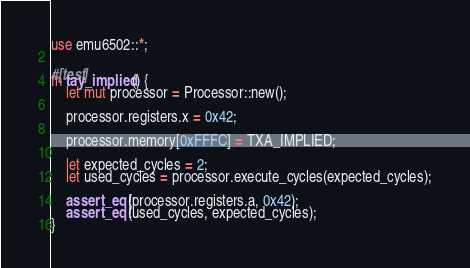Convert code to text. <code><loc_0><loc_0><loc_500><loc_500><_Rust_>use emu6502::*;

#[test]
fn tay_implied() {
    let mut processor = Processor::new();

    processor.registers.x = 0x42;

    processor.memory[0xFFFC] = TXA_IMPLIED;

    let expected_cycles = 2;
    let used_cycles = processor.execute_cycles(expected_cycles);

    assert_eq!(processor.registers.a, 0x42);
    assert_eq!(used_cycles, expected_cycles);
}
</code> 